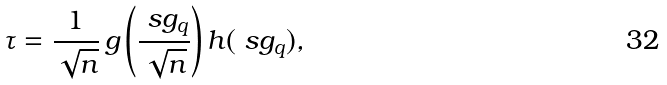Convert formula to latex. <formula><loc_0><loc_0><loc_500><loc_500>\tau = \frac { 1 } { \sqrt { n } } \, g \left ( \frac { \ s g _ { q } } { \sqrt { n } } \right ) h ( \ s g _ { q } ) ,</formula> 